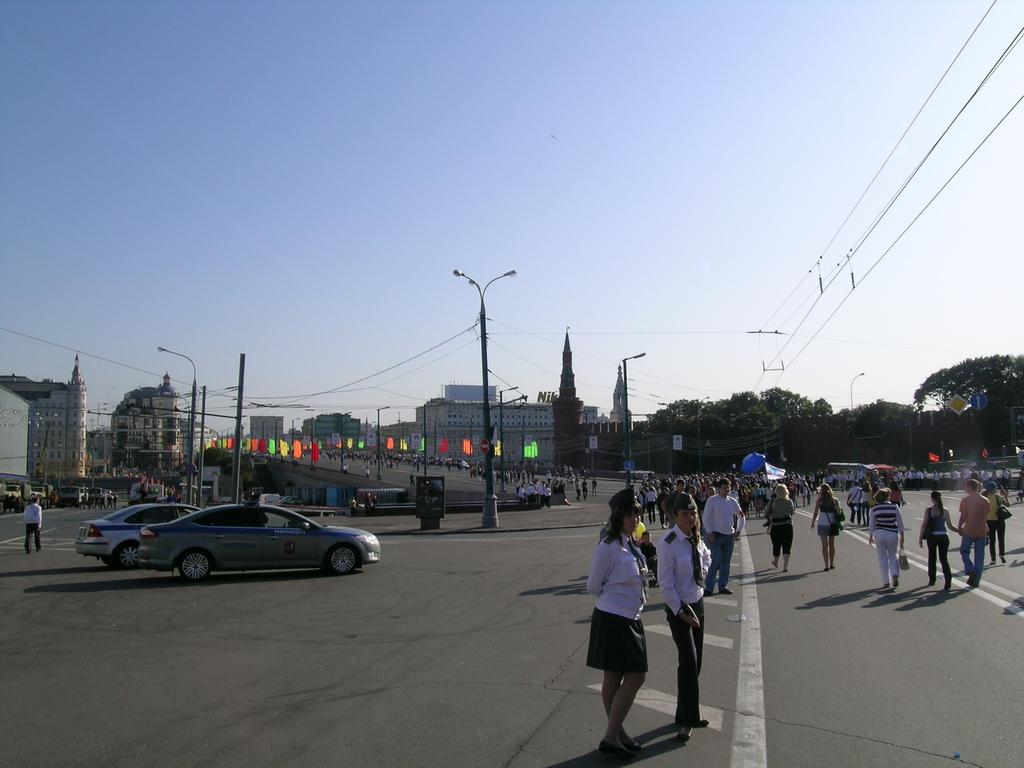What are the people in the image doing? There is a group of people walking on the road in the image. What else can be seen in the image besides the people? There are vehicles in the image. What objects are present in the image that are not vehicles or people? There are boards, trees, buildings, street poles, and wires in the image. What is visible in the background of the image? The sky is visible in the image, and it appears cloudy. What is the income of the people walking on the road in the image? There is no information about the income of the people walking on the road in the image. Can you see a cannon in the image? There is no cannon present in the image. 